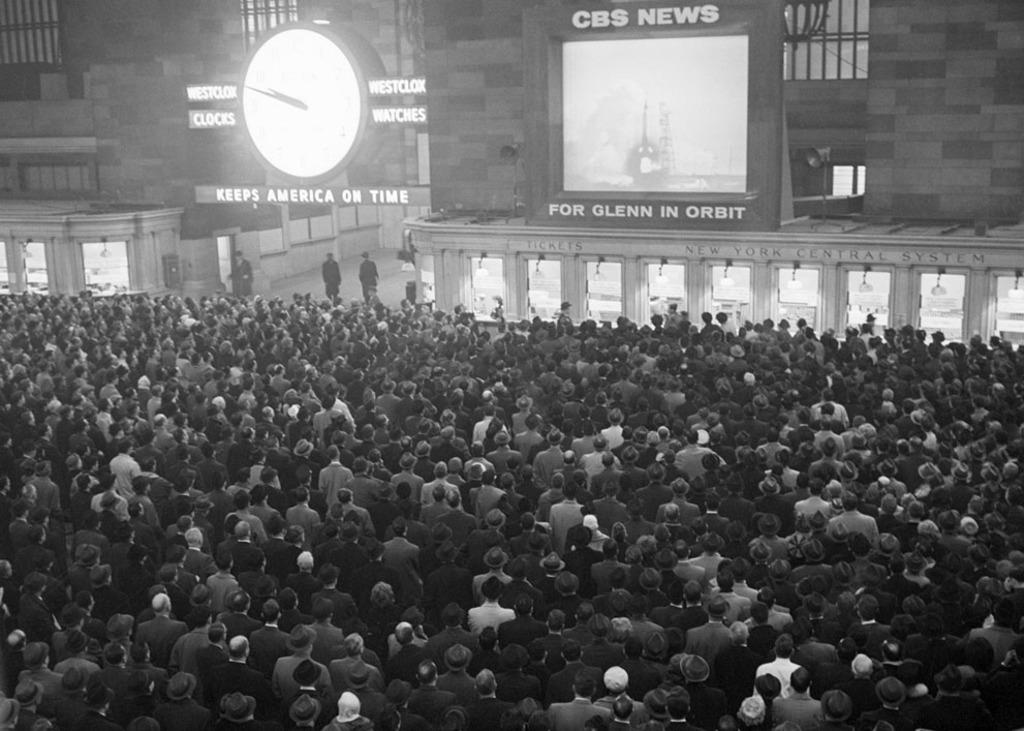What are the people in the image doing? The people in the image are watching the news. Can you describe the clock in the image? There is a white color clock on the left side of the image. What type of base is supporting the dog in the image? There is no dog present in the image, so there is no base supporting a dog. 